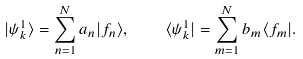<formula> <loc_0><loc_0><loc_500><loc_500>| \psi ^ { 1 } _ { k } \rangle = \sum _ { n = 1 } ^ { N } a _ { n } | f _ { n } \rangle , \quad \langle \psi ^ { 1 } _ { k } | = \sum _ { m = 1 } ^ { N } b _ { m } \langle f _ { m } | .</formula> 